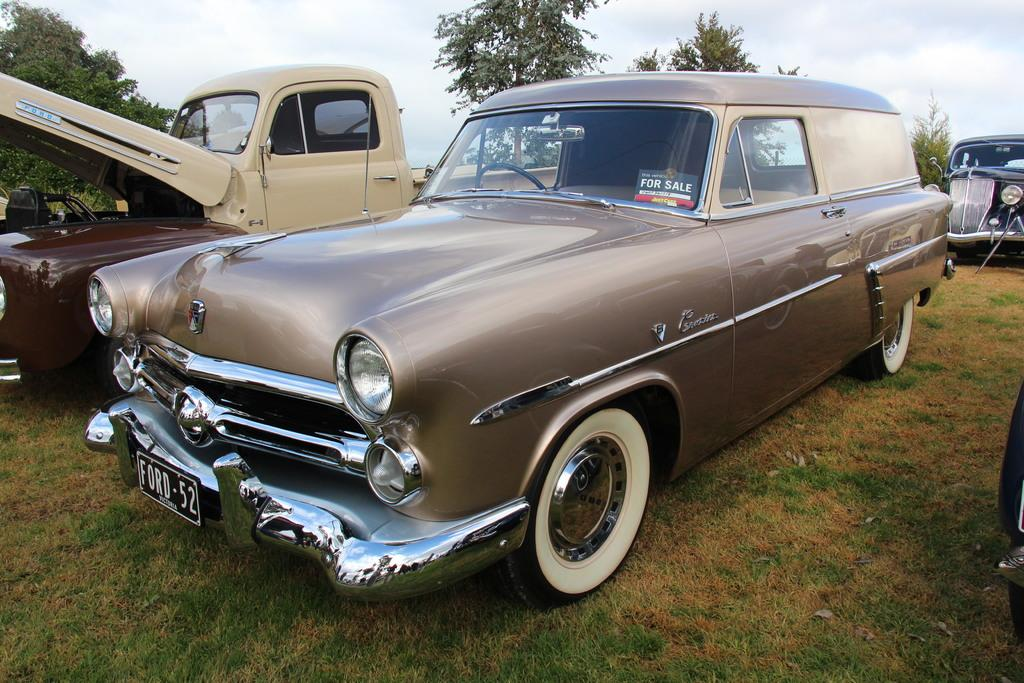<image>
Summarize the visual content of the image. An antique Ford hearse car has a For Sale sign in the window 